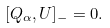<formula> <loc_0><loc_0><loc_500><loc_500>[ Q _ { \alpha } , U ] _ { - } = 0 .</formula> 